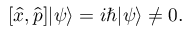<formula> <loc_0><loc_0><loc_500><loc_500>[ { \hat { x } } , { \hat { p } } ] | \psi \rangle = i \hbar { | } \psi \rangle \neq 0 .</formula> 